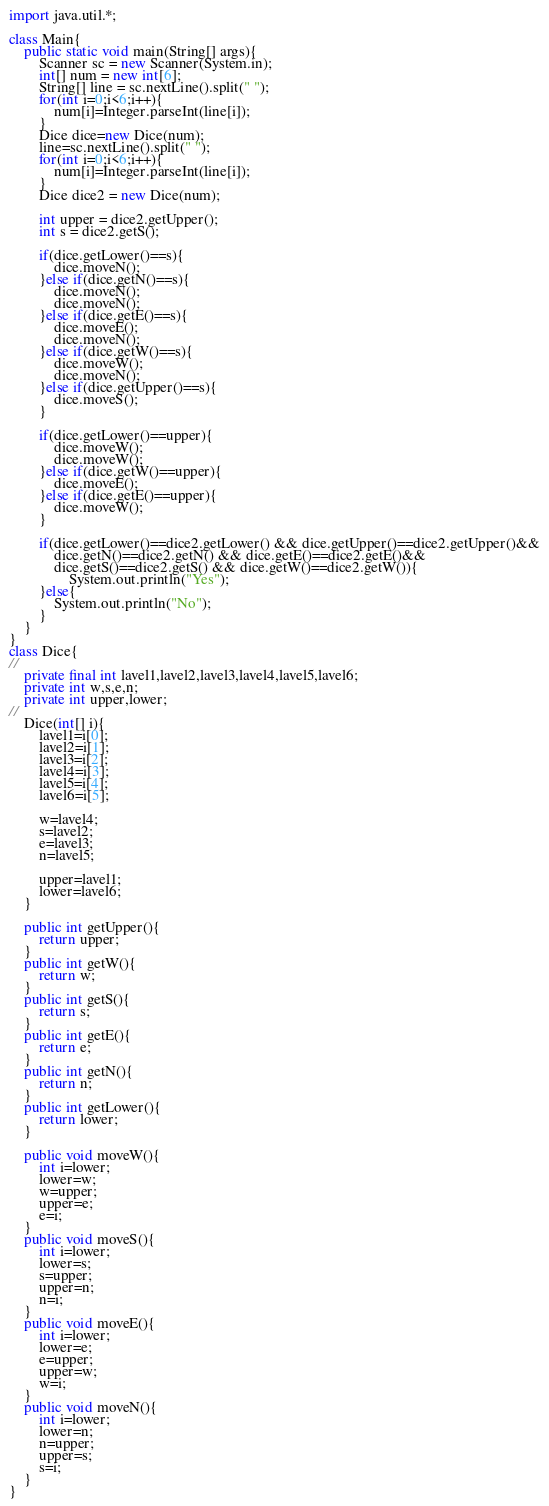<code> <loc_0><loc_0><loc_500><loc_500><_Java_>import java.util.*;

class Main{
	public static void main(String[] args){
		Scanner sc = new Scanner(System.in);
		int[] num = new int[6];
		String[] line = sc.nextLine().split(" ");
		for(int i=0;i<6;i++){
			num[i]=Integer.parseInt(line[i]);
		}
		Dice dice=new Dice(num);
		line=sc.nextLine().split(" ");
		for(int i=0;i<6;i++){
			num[i]=Integer.parseInt(line[i]);
		}
		Dice dice2 = new Dice(num);

		int upper = dice2.getUpper();
		int s = dice2.getS();
             
		if(dice.getLower()==s){
			dice.moveN();
		}else if(dice.getN()==s){
			dice.moveN();
			dice.moveN();
		}else if(dice.getE()==s){
			dice.moveE();
			dice.moveN();
		}else if(dice.getW()==s){
			dice.moveW();
			dice.moveN();
		}else if(dice.getUpper()==s){
			dice.moveS();
		}
             
		if(dice.getLower()==upper){
			dice.moveW();
			dice.moveW();
		}else if(dice.getW()==upper){
			dice.moveE();
		}else if(dice.getE()==upper){
			dice.moveW();
		}
		
		if(dice.getLower()==dice2.getLower() && dice.getUpper()==dice2.getUpper()&&
			dice.getN()==dice2.getN() && dice.getE()==dice2.getE()&&
			dice.getS()==dice2.getS() && dice.getW()==dice2.getW()){
				System.out.println("Yes");
		}else{
			System.out.println("No");
		}
	}
}
class Dice{
//
	private final int lavel1,lavel2,lavel3,lavel4,lavel5,lavel6;
	private int w,s,e,n;
	private int upper,lower;
//	
	Dice(int[] i){
		lavel1=i[0];
		lavel2=i[1];
		lavel3=i[2];
		lavel4=i[3];
		lavel5=i[4];
		lavel6=i[5];
		
		w=lavel4;
		s=lavel2;
		e=lavel3;
		n=lavel5;
		
		upper=lavel1;
		lower=lavel6;
	}
	
	public int getUpper(){
		return upper;
	}
	public int getW(){
		return w;
	}
	public int getS(){
		return s;
	}
	public int getE(){
		return e;
	}
	public int getN(){
		return n;
	}
	public int getLower(){
		return lower;
	}
	
	public void moveW(){
		int i=lower;
		lower=w;
		w=upper;
		upper=e;
		e=i;
	}
	public void moveS(){
		int i=lower;
		lower=s;
		s=upper;
		upper=n;
		n=i;
	}
	public void moveE(){
		int i=lower;
		lower=e;
		e=upper;
		upper=w;
		w=i;
	}
	public void moveN(){
		int i=lower;
		lower=n;
		n=upper;
		upper=s;
		s=i;
	}
}</code> 